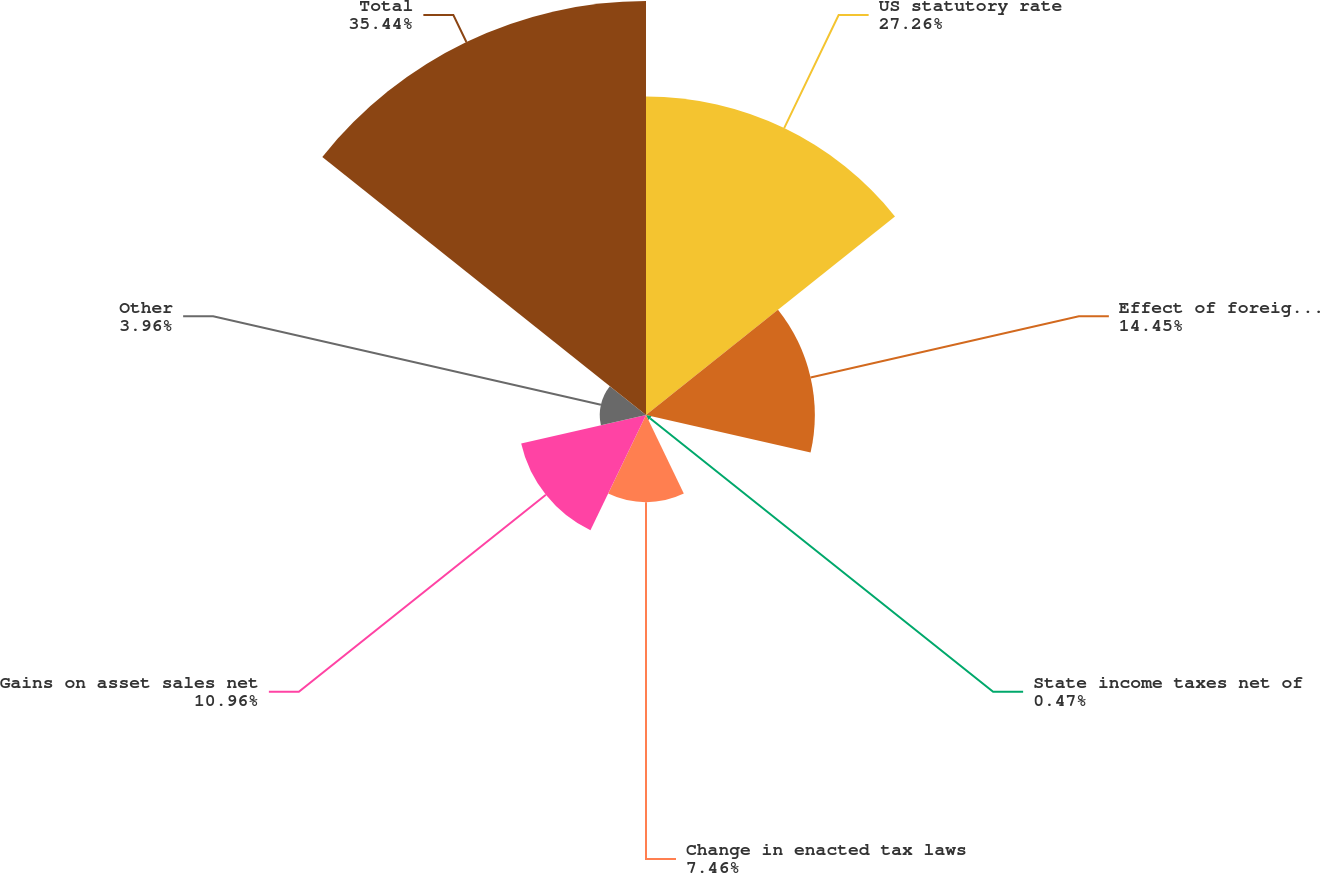<chart> <loc_0><loc_0><loc_500><loc_500><pie_chart><fcel>US statutory rate<fcel>Effect of foreign operations<fcel>State income taxes net of<fcel>Change in enacted tax laws<fcel>Gains on asset sales net<fcel>Other<fcel>Total<nl><fcel>27.26%<fcel>14.45%<fcel>0.47%<fcel>7.46%<fcel>10.96%<fcel>3.96%<fcel>35.44%<nl></chart> 